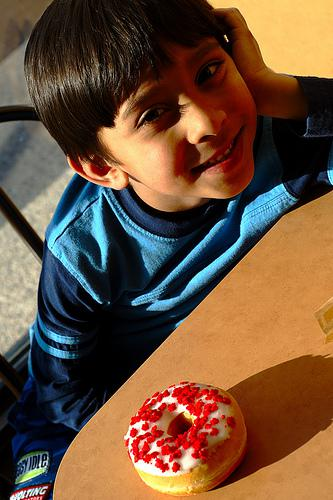Question: how many people are pictured?
Choices:
A. Two.
B. Three.
C. Four.
D. One.
Answer with the letter. Answer: D Question: what type of product is on the table?
Choices:
A. Drink.
B. Water.
C. Food.
D. Watermelon.
Answer with the letter. Answer: C Question: what color are the doughnut sprinkles?
Choices:
A. White.
B. Red.
C. Blue.
D. Tan.
Answer with the letter. Answer: B Question: where is the person in relation to the doughnut?
Choices:
A. Far right.
B. Far left.
C. Behind.
D. Up left.
Answer with the letter. Answer: C 